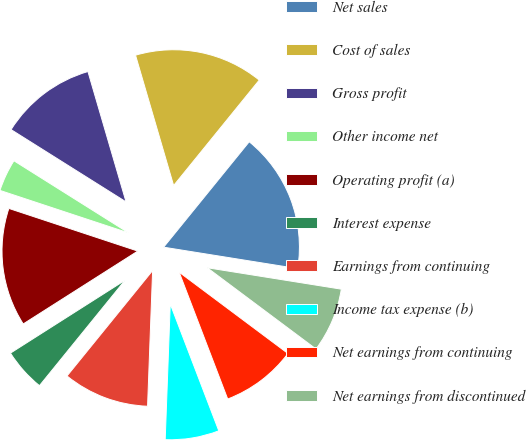<chart> <loc_0><loc_0><loc_500><loc_500><pie_chart><fcel>Net sales<fcel>Cost of sales<fcel>Gross profit<fcel>Other income net<fcel>Operating profit (a)<fcel>Interest expense<fcel>Earnings from continuing<fcel>Income tax expense (b)<fcel>Net earnings from continuing<fcel>Net earnings from discontinued<nl><fcel>16.67%<fcel>15.38%<fcel>11.54%<fcel>3.85%<fcel>14.1%<fcel>5.13%<fcel>10.26%<fcel>6.41%<fcel>8.97%<fcel>7.69%<nl></chart> 